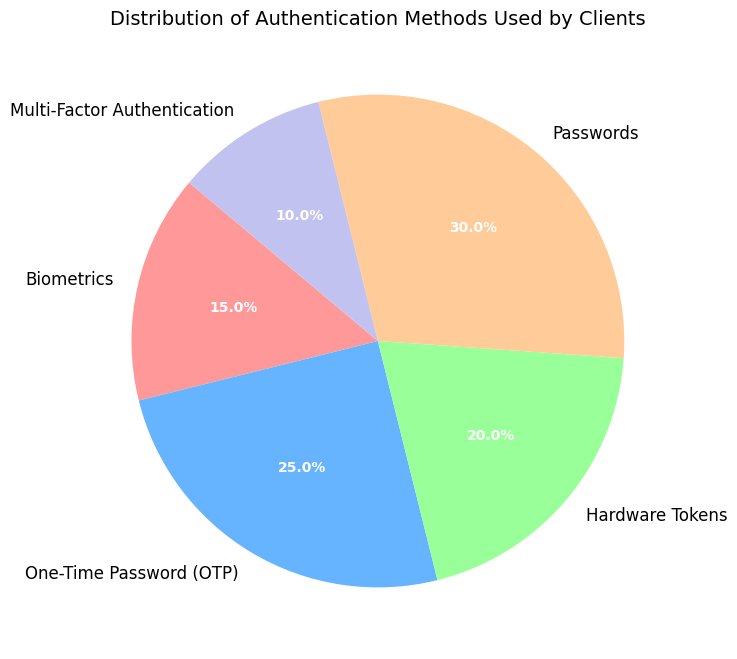What is the most commonly used authentication method among clients? The pie chart shows that Passwords have the largest segment. The percentage label on the Passwords segment reads 30%. Hence, Passwords are the most commonly used authentication method among clients.
Answer: Passwords What is the combined percentage of clients using Biometrics and Hardware Tokens? From the pie chart, the percentage of Biometrics is 15% and Hardware Tokens is 20%. Adding these together gives 15% + 20% = 35%. Therefore, the combined percentage of clients using Biometrics and Hardware Tokens is 35%.
Answer: 35% Which authentication method is the least commonly used among clients? The pie chart shows that Multi-Factor Authentication has the smallest segment. The percentage label on this segment reads 10%. Hence, Multi-Factor Authentication is the least commonly used authentication method among clients.
Answer: Multi-Factor Authentication How much more popular is OTP compared to Multi-Factor Authentication? According to the pie chart, the percentage of OTP users is 25%, and the percentage of Multi-Factor Authentication users is 10%. The difference is 25% - 10% = 15%. Therefore, OTP is 15% more popular than Multi-Factor Authentication.
Answer: 15% Are there more clients using OTP and Hardware Tokens combined than those using Passwords alone? The pie chart shows that OTP is used by 25% of clients and Hardware Tokens by 20%. Adding these percentages together gives 25% + 20% = 45%. Passwords are used by 30% of clients. Since 45% is greater than 30%, more clients use OTP and Hardware Tokens combined than Passwords alone.
Answer: Yes What percentage of clients do not use Passwords as an authentication method? According to the pie chart, Passwords are used by 30% of clients. To find the percentage not using Passwords, subtract 30% from 100%: 100% - 30% = 70%. Thus, 70% of clients do not use Passwords as an authentication method.
Answer: 70% Which two authentication methods, when combined, make up exactly half of the total authentication methods used by clients? According to the pie chart, Multi-Factor Authentication is 10%, and Passwords are 30%. Together, 10% + 30% = 40%, which isn't sufficient. Checking OTP and Biometrics, OTP is 25% and Biometrics is 15%. Adding these, 25% + 15% = 40%, still not half. But OTP and Hardware Tokens are 25% + 20% = 45%, still not half. The exact half combination isn’t possible with the given data. Given all the considered combinations, none total to exactly half. There is no correct combination in this dataset.
Answer: N/A 